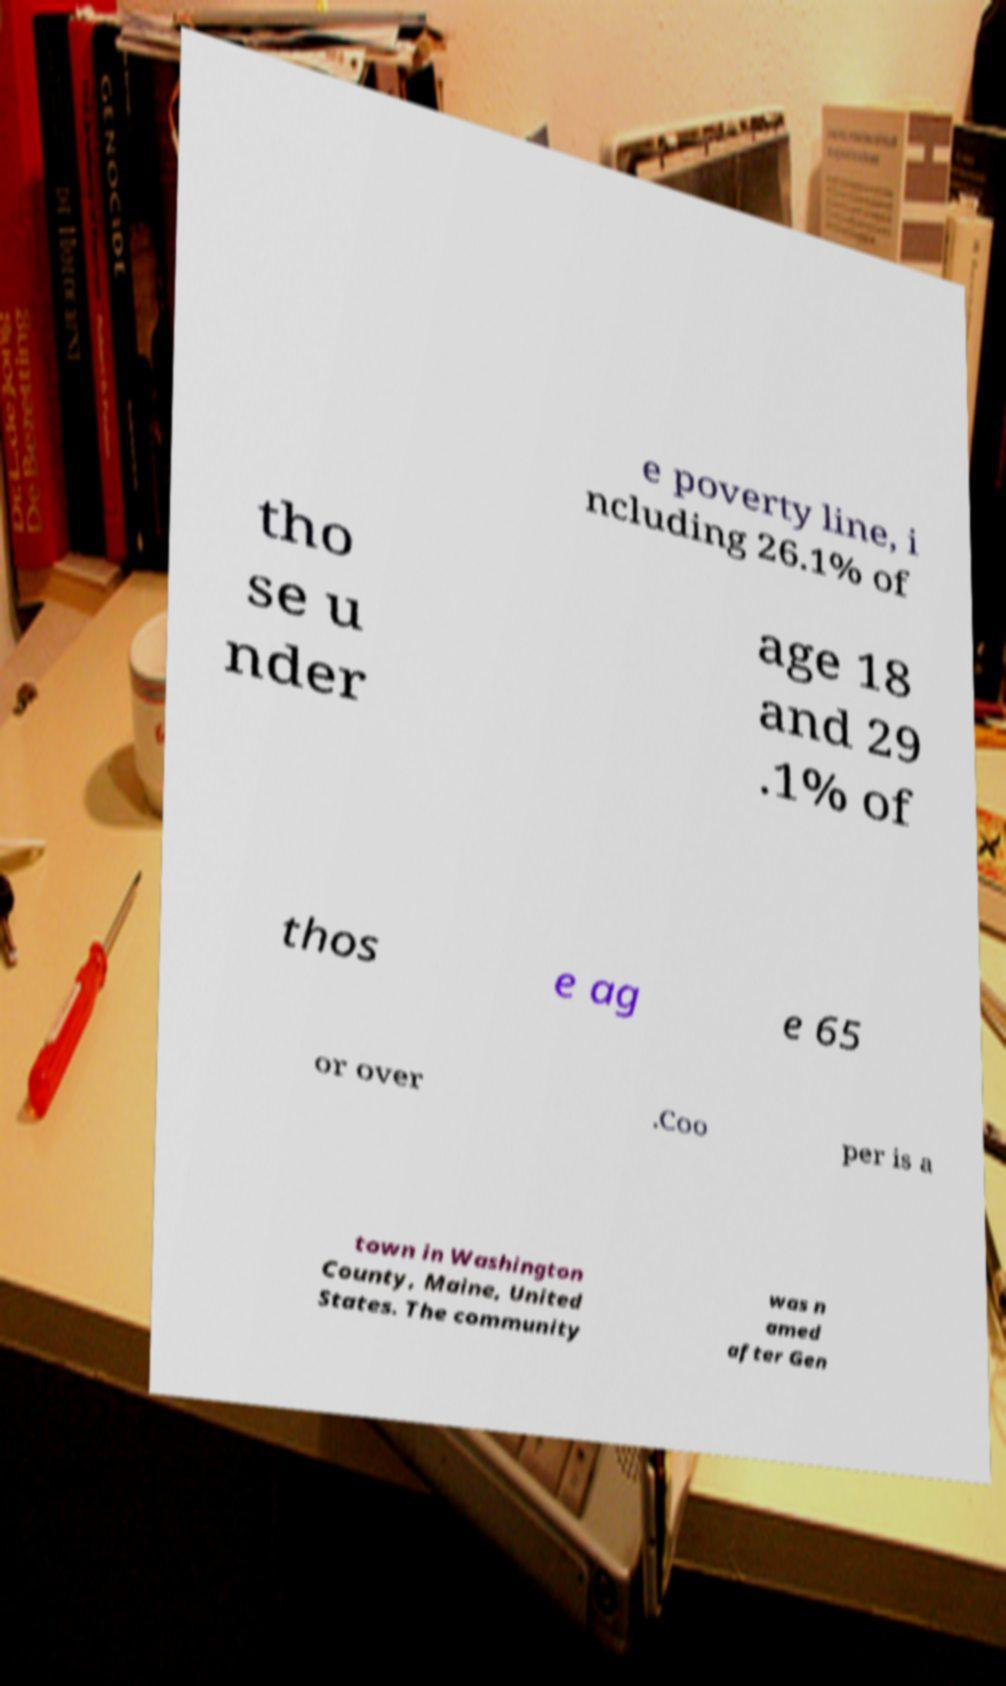Could you extract and type out the text from this image? e poverty line, i ncluding 26.1% of tho se u nder age 18 and 29 .1% of thos e ag e 65 or over .Coo per is a town in Washington County, Maine, United States. The community was n amed after Gen 